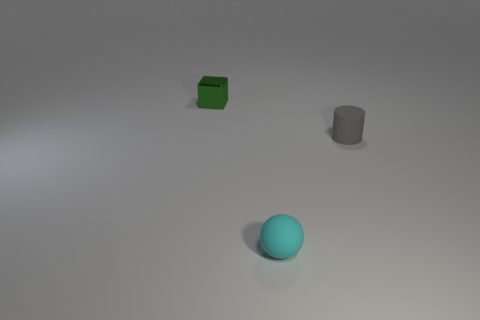What shape is the metallic object that is the same size as the cyan sphere?
Provide a succinct answer. Cube. What number of gray rubber cylinders are the same size as the shiny object?
Your response must be concise. 1. There is a tiny sphere that is the same material as the tiny gray object; what is its color?
Give a very brief answer. Cyan. Is the number of tiny green blocks that are left of the metallic object less than the number of tiny yellow cylinders?
Make the answer very short. No. There is a gray thing that is made of the same material as the sphere; what is its shape?
Give a very brief answer. Cylinder. What number of rubber things are either big cyan blocks or tiny green cubes?
Keep it short and to the point. 0. Are there the same number of tiny cyan objects that are on the right side of the gray object and large brown blocks?
Your answer should be compact. Yes. What material is the object that is both on the left side of the tiny gray object and behind the matte sphere?
Keep it short and to the point. Metal. There is a matte thing on the left side of the tiny gray cylinder; are there any tiny gray cylinders that are in front of it?
Make the answer very short. No. Do the cylinder and the small green thing have the same material?
Provide a succinct answer. No. 